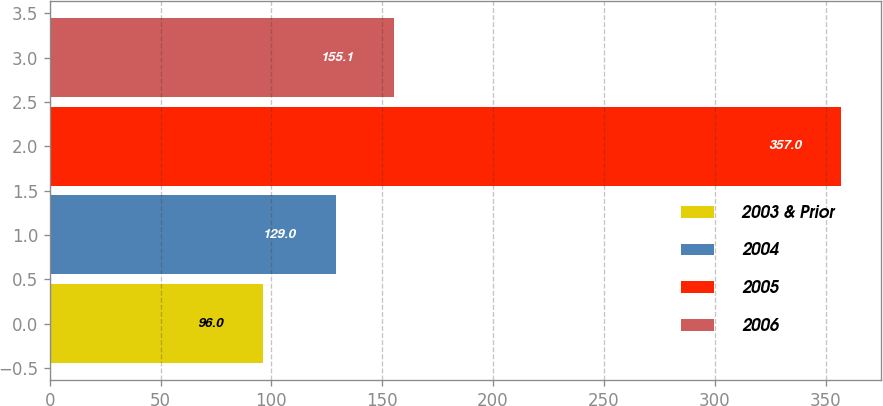Convert chart to OTSL. <chart><loc_0><loc_0><loc_500><loc_500><bar_chart><fcel>2003 & Prior<fcel>2004<fcel>2005<fcel>2006<nl><fcel>96<fcel>129<fcel>357<fcel>155.1<nl></chart> 